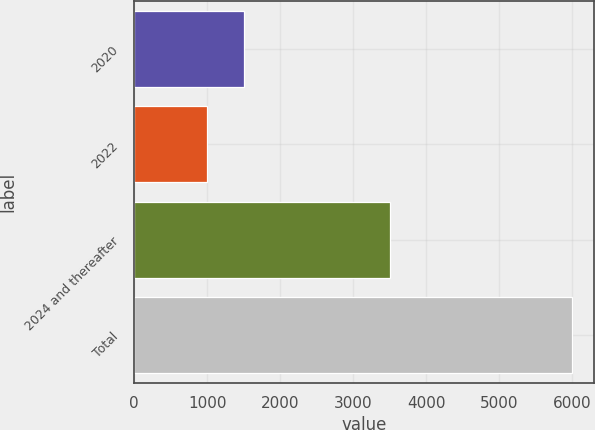<chart> <loc_0><loc_0><loc_500><loc_500><bar_chart><fcel>2020<fcel>2022<fcel>2024 and thereafter<fcel>Total<nl><fcel>1500<fcel>1000<fcel>3500<fcel>6000<nl></chart> 